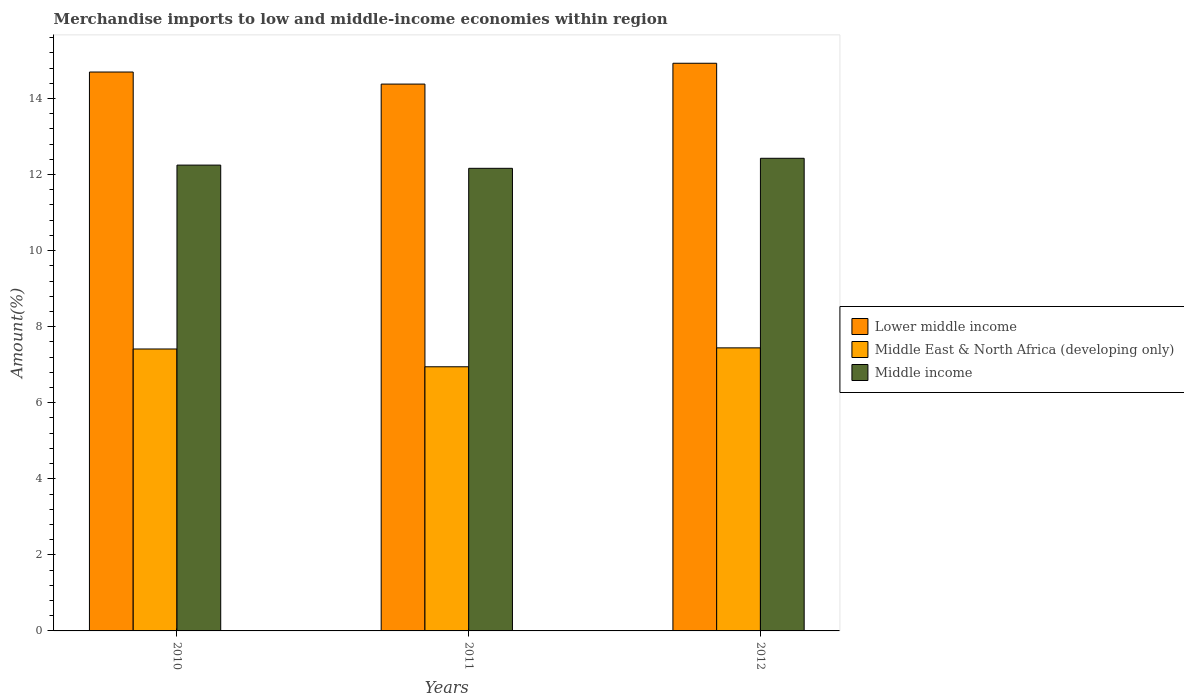Are the number of bars per tick equal to the number of legend labels?
Provide a short and direct response. Yes. How many bars are there on the 1st tick from the left?
Keep it short and to the point. 3. What is the label of the 3rd group of bars from the left?
Keep it short and to the point. 2012. What is the percentage of amount earned from merchandise imports in Lower middle income in 2011?
Your answer should be compact. 14.38. Across all years, what is the maximum percentage of amount earned from merchandise imports in Middle East & North Africa (developing only)?
Provide a short and direct response. 7.44. Across all years, what is the minimum percentage of amount earned from merchandise imports in Lower middle income?
Your response must be concise. 14.38. In which year was the percentage of amount earned from merchandise imports in Middle income minimum?
Ensure brevity in your answer.  2011. What is the total percentage of amount earned from merchandise imports in Middle income in the graph?
Provide a succinct answer. 36.84. What is the difference between the percentage of amount earned from merchandise imports in Middle income in 2010 and that in 2011?
Provide a short and direct response. 0.08. What is the difference between the percentage of amount earned from merchandise imports in Middle East & North Africa (developing only) in 2011 and the percentage of amount earned from merchandise imports in Lower middle income in 2010?
Ensure brevity in your answer.  -7.75. What is the average percentage of amount earned from merchandise imports in Middle East & North Africa (developing only) per year?
Keep it short and to the point. 7.27. In the year 2012, what is the difference between the percentage of amount earned from merchandise imports in Middle income and percentage of amount earned from merchandise imports in Lower middle income?
Your answer should be compact. -2.5. In how many years, is the percentage of amount earned from merchandise imports in Lower middle income greater than 2.8 %?
Your answer should be compact. 3. What is the ratio of the percentage of amount earned from merchandise imports in Middle income in 2010 to that in 2012?
Your response must be concise. 0.99. Is the difference between the percentage of amount earned from merchandise imports in Middle income in 2011 and 2012 greater than the difference between the percentage of amount earned from merchandise imports in Lower middle income in 2011 and 2012?
Your response must be concise. Yes. What is the difference between the highest and the second highest percentage of amount earned from merchandise imports in Middle income?
Ensure brevity in your answer.  0.18. What is the difference between the highest and the lowest percentage of amount earned from merchandise imports in Middle East & North Africa (developing only)?
Ensure brevity in your answer.  0.5. Is the sum of the percentage of amount earned from merchandise imports in Middle East & North Africa (developing only) in 2010 and 2012 greater than the maximum percentage of amount earned from merchandise imports in Middle income across all years?
Your response must be concise. Yes. What does the 2nd bar from the left in 2010 represents?
Offer a very short reply. Middle East & North Africa (developing only). What does the 2nd bar from the right in 2010 represents?
Offer a very short reply. Middle East & North Africa (developing only). How many bars are there?
Your response must be concise. 9. Are all the bars in the graph horizontal?
Give a very brief answer. No. How many years are there in the graph?
Make the answer very short. 3. What is the difference between two consecutive major ticks on the Y-axis?
Offer a very short reply. 2. Are the values on the major ticks of Y-axis written in scientific E-notation?
Your answer should be very brief. No. How many legend labels are there?
Keep it short and to the point. 3. What is the title of the graph?
Provide a short and direct response. Merchandise imports to low and middle-income economies within region. What is the label or title of the Y-axis?
Provide a succinct answer. Amount(%). What is the Amount(%) in Lower middle income in 2010?
Your answer should be compact. 14.7. What is the Amount(%) in Middle East & North Africa (developing only) in 2010?
Your answer should be compact. 7.41. What is the Amount(%) in Middle income in 2010?
Make the answer very short. 12.25. What is the Amount(%) of Lower middle income in 2011?
Give a very brief answer. 14.38. What is the Amount(%) of Middle East & North Africa (developing only) in 2011?
Your answer should be compact. 6.95. What is the Amount(%) of Middle income in 2011?
Provide a short and direct response. 12.16. What is the Amount(%) in Lower middle income in 2012?
Make the answer very short. 14.93. What is the Amount(%) in Middle East & North Africa (developing only) in 2012?
Your answer should be compact. 7.44. What is the Amount(%) of Middle income in 2012?
Offer a very short reply. 12.43. Across all years, what is the maximum Amount(%) of Lower middle income?
Make the answer very short. 14.93. Across all years, what is the maximum Amount(%) in Middle East & North Africa (developing only)?
Make the answer very short. 7.44. Across all years, what is the maximum Amount(%) in Middle income?
Provide a short and direct response. 12.43. Across all years, what is the minimum Amount(%) in Lower middle income?
Make the answer very short. 14.38. Across all years, what is the minimum Amount(%) of Middle East & North Africa (developing only)?
Give a very brief answer. 6.95. Across all years, what is the minimum Amount(%) in Middle income?
Your answer should be compact. 12.16. What is the total Amount(%) in Middle East & North Africa (developing only) in the graph?
Provide a succinct answer. 21.8. What is the total Amount(%) of Middle income in the graph?
Your answer should be compact. 36.84. What is the difference between the Amount(%) of Lower middle income in 2010 and that in 2011?
Make the answer very short. 0.32. What is the difference between the Amount(%) in Middle East & North Africa (developing only) in 2010 and that in 2011?
Provide a succinct answer. 0.47. What is the difference between the Amount(%) of Middle income in 2010 and that in 2011?
Keep it short and to the point. 0.08. What is the difference between the Amount(%) of Lower middle income in 2010 and that in 2012?
Provide a short and direct response. -0.23. What is the difference between the Amount(%) of Middle East & North Africa (developing only) in 2010 and that in 2012?
Offer a very short reply. -0.03. What is the difference between the Amount(%) in Middle income in 2010 and that in 2012?
Give a very brief answer. -0.18. What is the difference between the Amount(%) of Lower middle income in 2011 and that in 2012?
Your answer should be compact. -0.55. What is the difference between the Amount(%) of Middle East & North Africa (developing only) in 2011 and that in 2012?
Your response must be concise. -0.5. What is the difference between the Amount(%) in Middle income in 2011 and that in 2012?
Offer a very short reply. -0.26. What is the difference between the Amount(%) in Lower middle income in 2010 and the Amount(%) in Middle East & North Africa (developing only) in 2011?
Give a very brief answer. 7.75. What is the difference between the Amount(%) in Lower middle income in 2010 and the Amount(%) in Middle income in 2011?
Your response must be concise. 2.53. What is the difference between the Amount(%) of Middle East & North Africa (developing only) in 2010 and the Amount(%) of Middle income in 2011?
Offer a very short reply. -4.75. What is the difference between the Amount(%) of Lower middle income in 2010 and the Amount(%) of Middle East & North Africa (developing only) in 2012?
Give a very brief answer. 7.25. What is the difference between the Amount(%) of Lower middle income in 2010 and the Amount(%) of Middle income in 2012?
Provide a short and direct response. 2.27. What is the difference between the Amount(%) in Middle East & North Africa (developing only) in 2010 and the Amount(%) in Middle income in 2012?
Offer a very short reply. -5.01. What is the difference between the Amount(%) of Lower middle income in 2011 and the Amount(%) of Middle East & North Africa (developing only) in 2012?
Provide a short and direct response. 6.94. What is the difference between the Amount(%) of Lower middle income in 2011 and the Amount(%) of Middle income in 2012?
Give a very brief answer. 1.95. What is the difference between the Amount(%) in Middle East & North Africa (developing only) in 2011 and the Amount(%) in Middle income in 2012?
Provide a succinct answer. -5.48. What is the average Amount(%) in Lower middle income per year?
Provide a short and direct response. 14.67. What is the average Amount(%) in Middle East & North Africa (developing only) per year?
Your answer should be very brief. 7.27. What is the average Amount(%) in Middle income per year?
Make the answer very short. 12.28. In the year 2010, what is the difference between the Amount(%) in Lower middle income and Amount(%) in Middle East & North Africa (developing only)?
Make the answer very short. 7.28. In the year 2010, what is the difference between the Amount(%) of Lower middle income and Amount(%) of Middle income?
Your answer should be very brief. 2.45. In the year 2010, what is the difference between the Amount(%) in Middle East & North Africa (developing only) and Amount(%) in Middle income?
Ensure brevity in your answer.  -4.84. In the year 2011, what is the difference between the Amount(%) in Lower middle income and Amount(%) in Middle East & North Africa (developing only)?
Give a very brief answer. 7.43. In the year 2011, what is the difference between the Amount(%) of Lower middle income and Amount(%) of Middle income?
Your response must be concise. 2.21. In the year 2011, what is the difference between the Amount(%) of Middle East & North Africa (developing only) and Amount(%) of Middle income?
Your answer should be very brief. -5.22. In the year 2012, what is the difference between the Amount(%) in Lower middle income and Amount(%) in Middle East & North Africa (developing only)?
Give a very brief answer. 7.48. In the year 2012, what is the difference between the Amount(%) in Lower middle income and Amount(%) in Middle income?
Keep it short and to the point. 2.5. In the year 2012, what is the difference between the Amount(%) of Middle East & North Africa (developing only) and Amount(%) of Middle income?
Your response must be concise. -4.98. What is the ratio of the Amount(%) of Lower middle income in 2010 to that in 2011?
Your answer should be very brief. 1.02. What is the ratio of the Amount(%) in Middle East & North Africa (developing only) in 2010 to that in 2011?
Offer a terse response. 1.07. What is the ratio of the Amount(%) in Lower middle income in 2010 to that in 2012?
Make the answer very short. 0.98. What is the ratio of the Amount(%) in Middle income in 2010 to that in 2012?
Give a very brief answer. 0.99. What is the ratio of the Amount(%) in Lower middle income in 2011 to that in 2012?
Provide a short and direct response. 0.96. What is the ratio of the Amount(%) of Middle East & North Africa (developing only) in 2011 to that in 2012?
Provide a succinct answer. 0.93. What is the ratio of the Amount(%) in Middle income in 2011 to that in 2012?
Your answer should be compact. 0.98. What is the difference between the highest and the second highest Amount(%) in Lower middle income?
Provide a succinct answer. 0.23. What is the difference between the highest and the second highest Amount(%) of Middle East & North Africa (developing only)?
Ensure brevity in your answer.  0.03. What is the difference between the highest and the second highest Amount(%) in Middle income?
Your response must be concise. 0.18. What is the difference between the highest and the lowest Amount(%) in Lower middle income?
Provide a succinct answer. 0.55. What is the difference between the highest and the lowest Amount(%) in Middle East & North Africa (developing only)?
Provide a succinct answer. 0.5. What is the difference between the highest and the lowest Amount(%) of Middle income?
Ensure brevity in your answer.  0.26. 